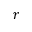Convert formula to latex. <formula><loc_0><loc_0><loc_500><loc_500>r</formula> 